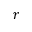Convert formula to latex. <formula><loc_0><loc_0><loc_500><loc_500>r</formula> 